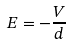<formula> <loc_0><loc_0><loc_500><loc_500>E = - \frac { V } { d }</formula> 